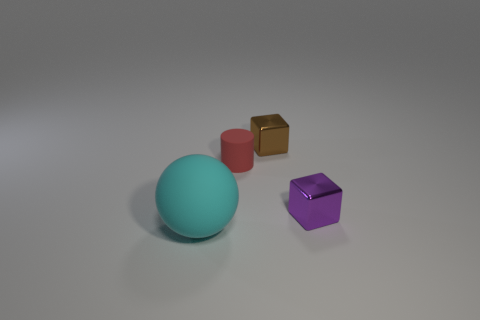Are there any other things that are the same size as the ball?
Offer a terse response. No. What material is the red object that is in front of the tiny cube behind the cube that is on the right side of the brown thing?
Ensure brevity in your answer.  Rubber. Is the number of small red rubber cylinders greater than the number of gray matte blocks?
Your answer should be compact. Yes. Is there anything else of the same color as the big rubber thing?
Keep it short and to the point. No. What size is the ball that is the same material as the tiny red object?
Offer a terse response. Large. What material is the red object?
Offer a terse response. Rubber. How many brown shiny spheres have the same size as the brown block?
Your answer should be very brief. 0. Are there any large green shiny things that have the same shape as the big cyan thing?
Ensure brevity in your answer.  No. The cylinder that is the same size as the brown metal block is what color?
Offer a very short reply. Red. The small shiny object that is left of the shiny object in front of the red cylinder is what color?
Provide a succinct answer. Brown. 